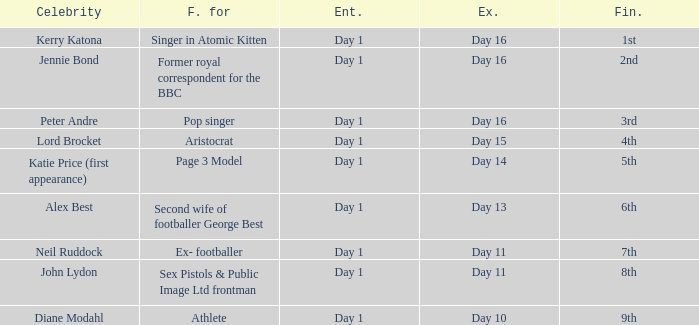Name the finished for exited day 13 6th. Can you parse all the data within this table? {'header': ['Celebrity', 'F. for', 'Ent.', 'Ex.', 'Fin.'], 'rows': [['Kerry Katona', 'Singer in Atomic Kitten', 'Day 1', 'Day 16', '1st'], ['Jennie Bond', 'Former royal correspondent for the BBC', 'Day 1', 'Day 16', '2nd'], ['Peter Andre', 'Pop singer', 'Day 1', 'Day 16', '3rd'], ['Lord Brocket', 'Aristocrat', 'Day 1', 'Day 15', '4th'], ['Katie Price (first appearance)', 'Page 3 Model', 'Day 1', 'Day 14', '5th'], ['Alex Best', 'Second wife of footballer George Best', 'Day 1', 'Day 13', '6th'], ['Neil Ruddock', 'Ex- footballer', 'Day 1', 'Day 11', '7th'], ['John Lydon', 'Sex Pistols & Public Image Ltd frontman', 'Day 1', 'Day 11', '8th'], ['Diane Modahl', 'Athlete', 'Day 1', 'Day 10', '9th']]} 